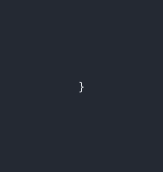Convert code to text. <code><loc_0><loc_0><loc_500><loc_500><_Kotlin_>


}</code> 